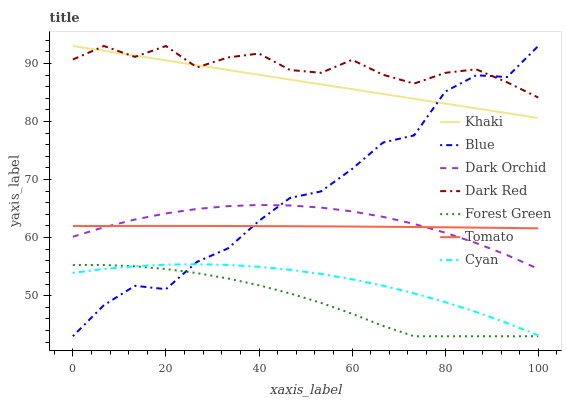Does Forest Green have the minimum area under the curve?
Answer yes or no. Yes. Does Dark Red have the maximum area under the curve?
Answer yes or no. Yes. Does Tomato have the minimum area under the curve?
Answer yes or no. No. Does Tomato have the maximum area under the curve?
Answer yes or no. No. Is Khaki the smoothest?
Answer yes or no. Yes. Is Blue the roughest?
Answer yes or no. Yes. Is Tomato the smoothest?
Answer yes or no. No. Is Tomato the roughest?
Answer yes or no. No. Does Blue have the lowest value?
Answer yes or no. Yes. Does Tomato have the lowest value?
Answer yes or no. No. Does Dark Red have the highest value?
Answer yes or no. Yes. Does Tomato have the highest value?
Answer yes or no. No. Is Forest Green less than Dark Orchid?
Answer yes or no. Yes. Is Khaki greater than Dark Orchid?
Answer yes or no. Yes. Does Dark Red intersect Khaki?
Answer yes or no. Yes. Is Dark Red less than Khaki?
Answer yes or no. No. Is Dark Red greater than Khaki?
Answer yes or no. No. Does Forest Green intersect Dark Orchid?
Answer yes or no. No. 